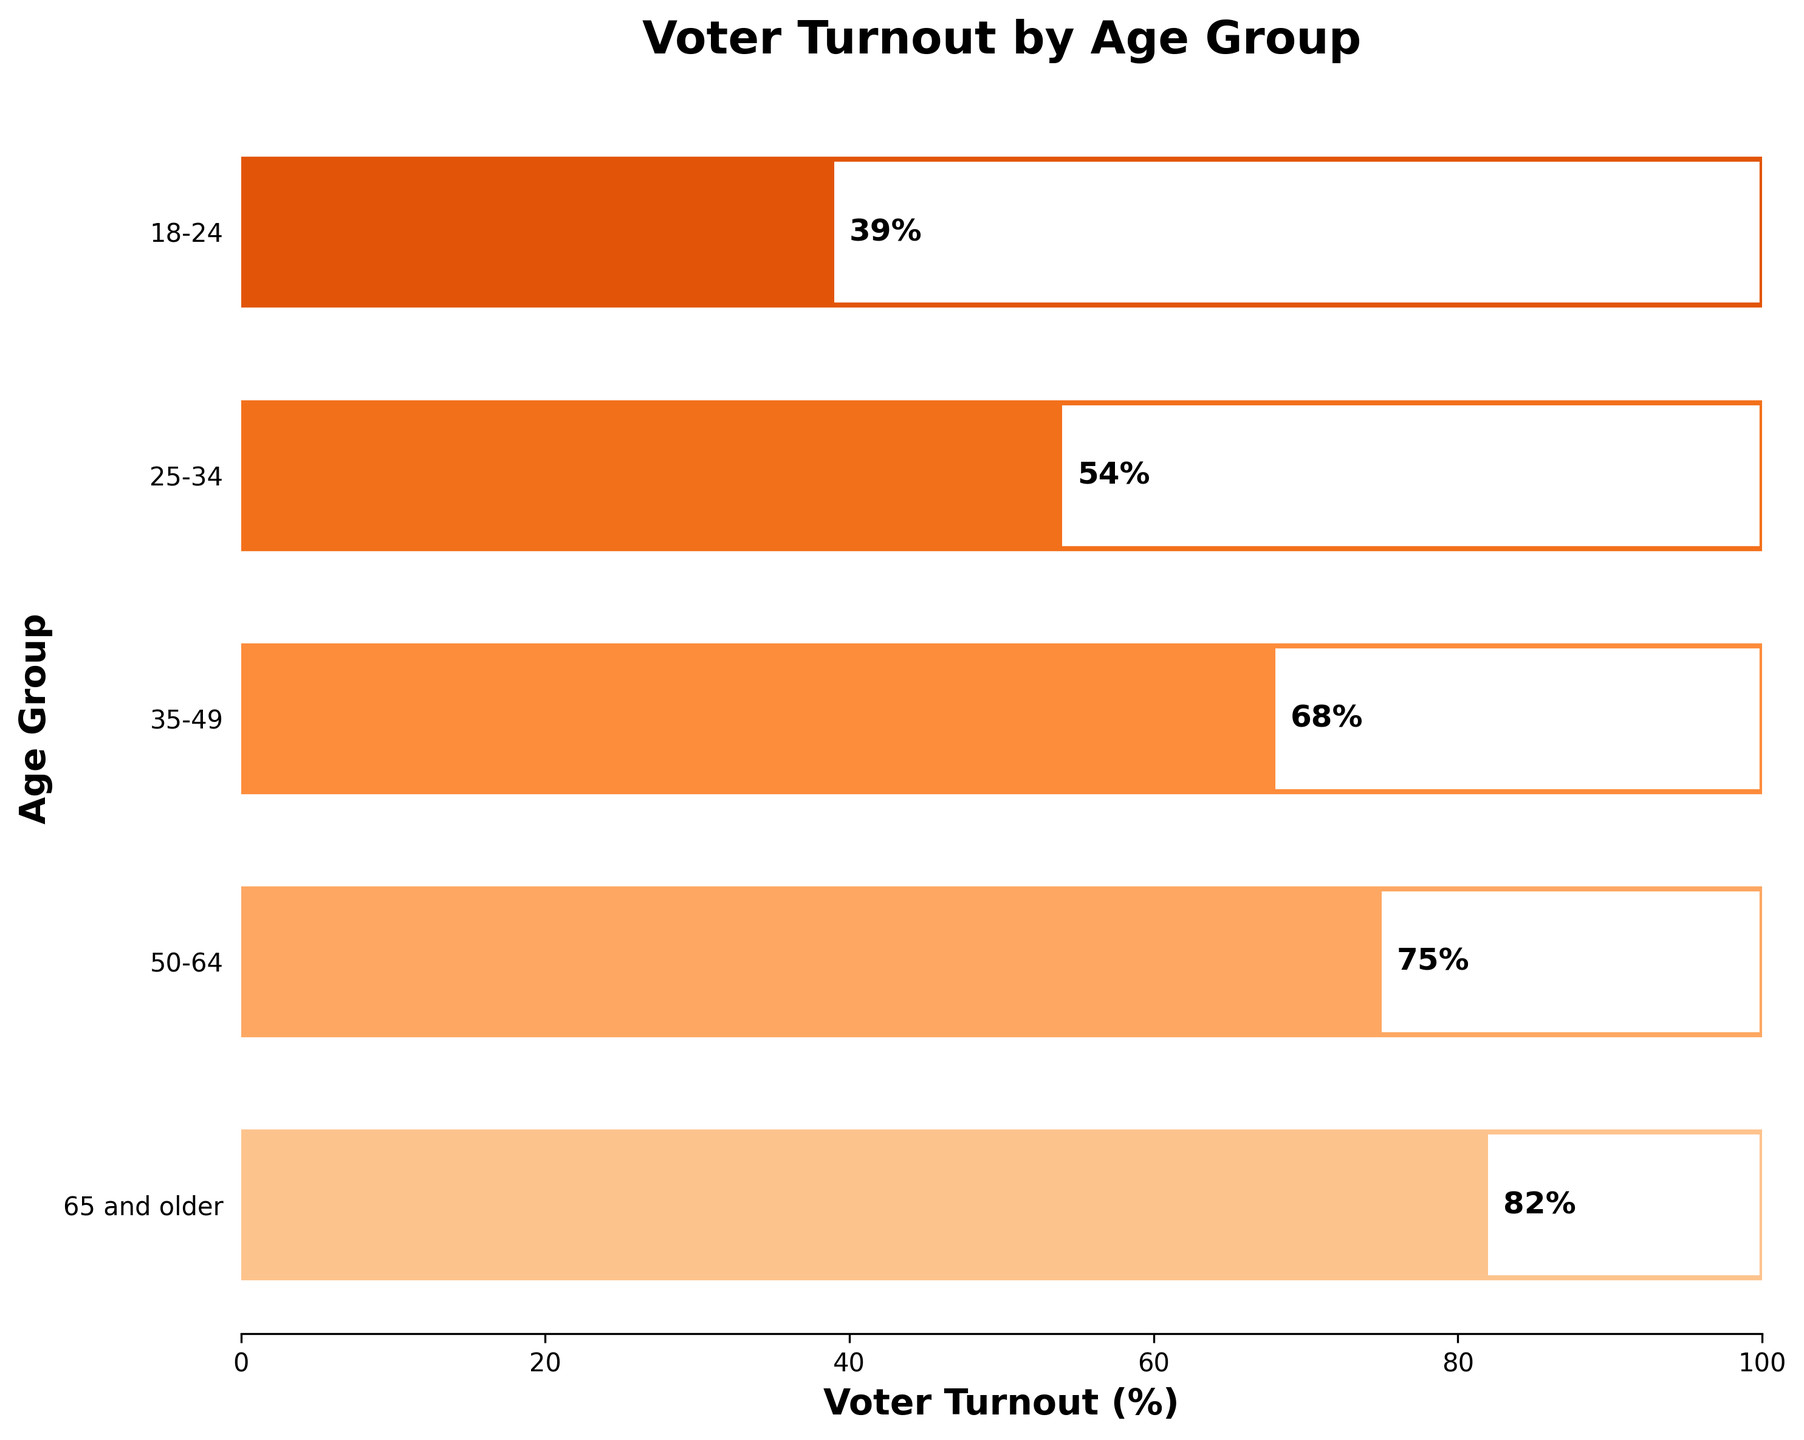What's the title of the chart? The title of the chart is displayed at the top in bold font. It reads "Voter Turnout by Age Group"
Answer: Voter Turnout by Age Group How is the voter turnout for the 25-34 age group visually represented? The voter turnout for the 25-34 age group is represented as a horizontal bar in the middle part of the chart. The bar extends to cover 54% on the horizontal axis, and the exact percentage is also written next to the bar.
Answer: A horizontal bar extending to 54% Which age group has the lowest voter turnout? The lowest bar on the chart corresponds to the 18-24 age group and extends to 39%. This makes it the smallest value visually on the bar chart.
Answer: 18-24 How much higher is the voter turnout for the 65 and older age group compared to the 18-24 age group? The turnout for the 65 and older age group is 82%. For the 18-24 age group, it is 39%. The difference is calculated as 82% - 39%.
Answer: 43% What is the average voter turnout across all age groups? The voter turnout percentages are: 82%, 75%, 68%, 54%, and 39%. To find the average, sum these values and divide by the number of age groups. (82+75+68+54+39) / 5 = 63.6%
Answer: 63.6% Compare the voter turnout for the 50-64 age group and 35-49 age group. Which group has a higher turnout and by how much? The voter turnout for the 50-64 age group is 75%, and for the 35-49 age group, it is 68%. The difference is calculated as 75% - 68%.
Answer: 50-64 by 7% Which age group shows a voter turnout closest to the overall average voter turnout? The overall average turnout is 63.6%. The voter turnouts are 82%, 75%, 68%, 54%, and 39%. The closest value to 63.6% is 68%.
Answer: 35-49 How is the color gradient applied to indicate voter turnout percentages? The color gradient in the chart is applied from lighter to darker shades of orange as the voter turnout percentage increases from the bottom to the top of the chart. Each bar's color deepens as turnout values rise.
Answer: From lighter to darker shades of orange Which age groups have a voter turnout that exceeds 50%? The age groups listed as 65 and older, 50-64, 35-49, and 25-34 have voter turnouts of 82%, 75%, 68%, and 54%, respectively, which are all above 50%.
Answer: 65 and older, 50-64, 35-49, 25-34 